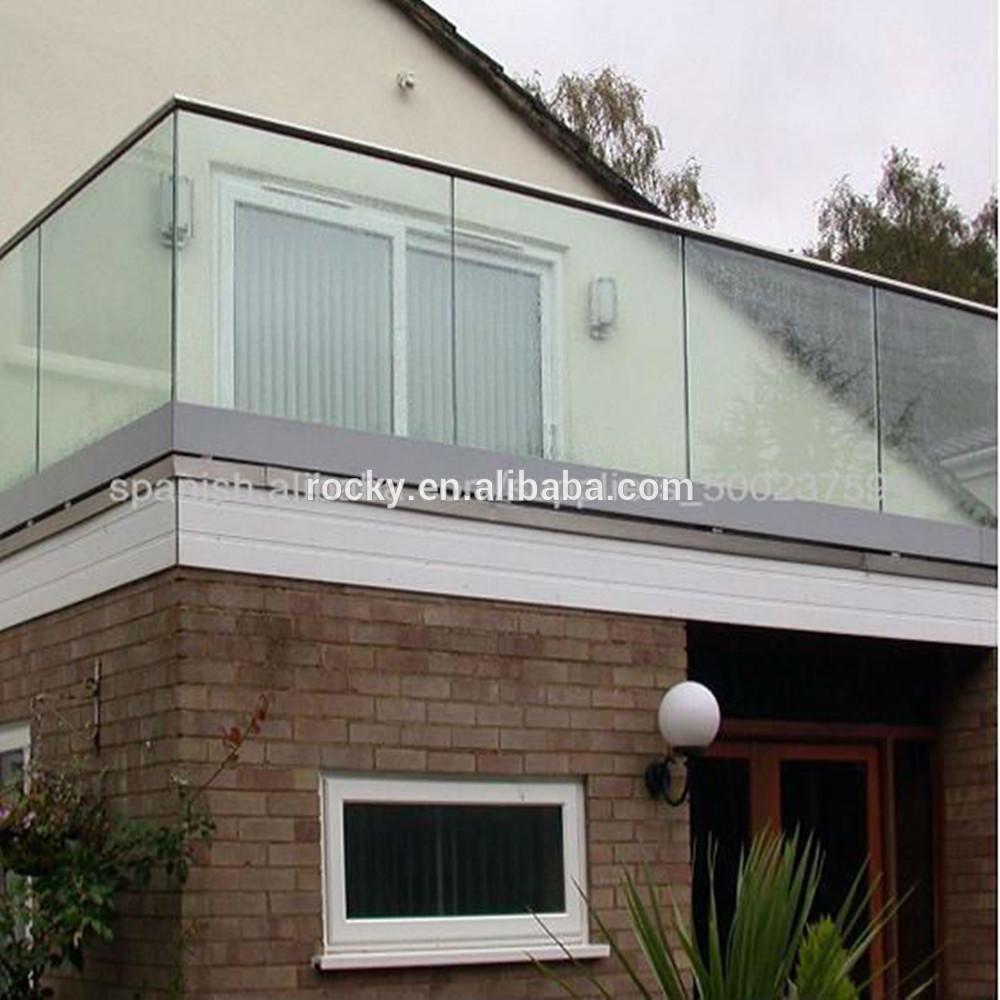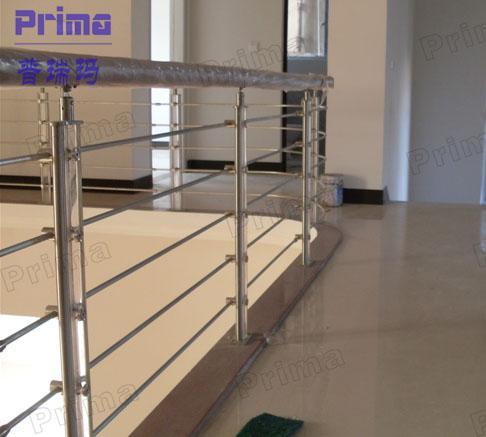The first image is the image on the left, the second image is the image on the right. Analyze the images presented: Is the assertion "One image shows a glass-paneled balcony with a corner on the left, a flat metal rail across the top, and no hinges connecting the balcony panels, and the other image shows a railing with horizontal bars." valid? Answer yes or no. Yes. The first image is the image on the left, the second image is the image on the right. Evaluate the accuracy of this statement regarding the images: "The building in the image on the right is made of bricks.". Is it true? Answer yes or no. No. 